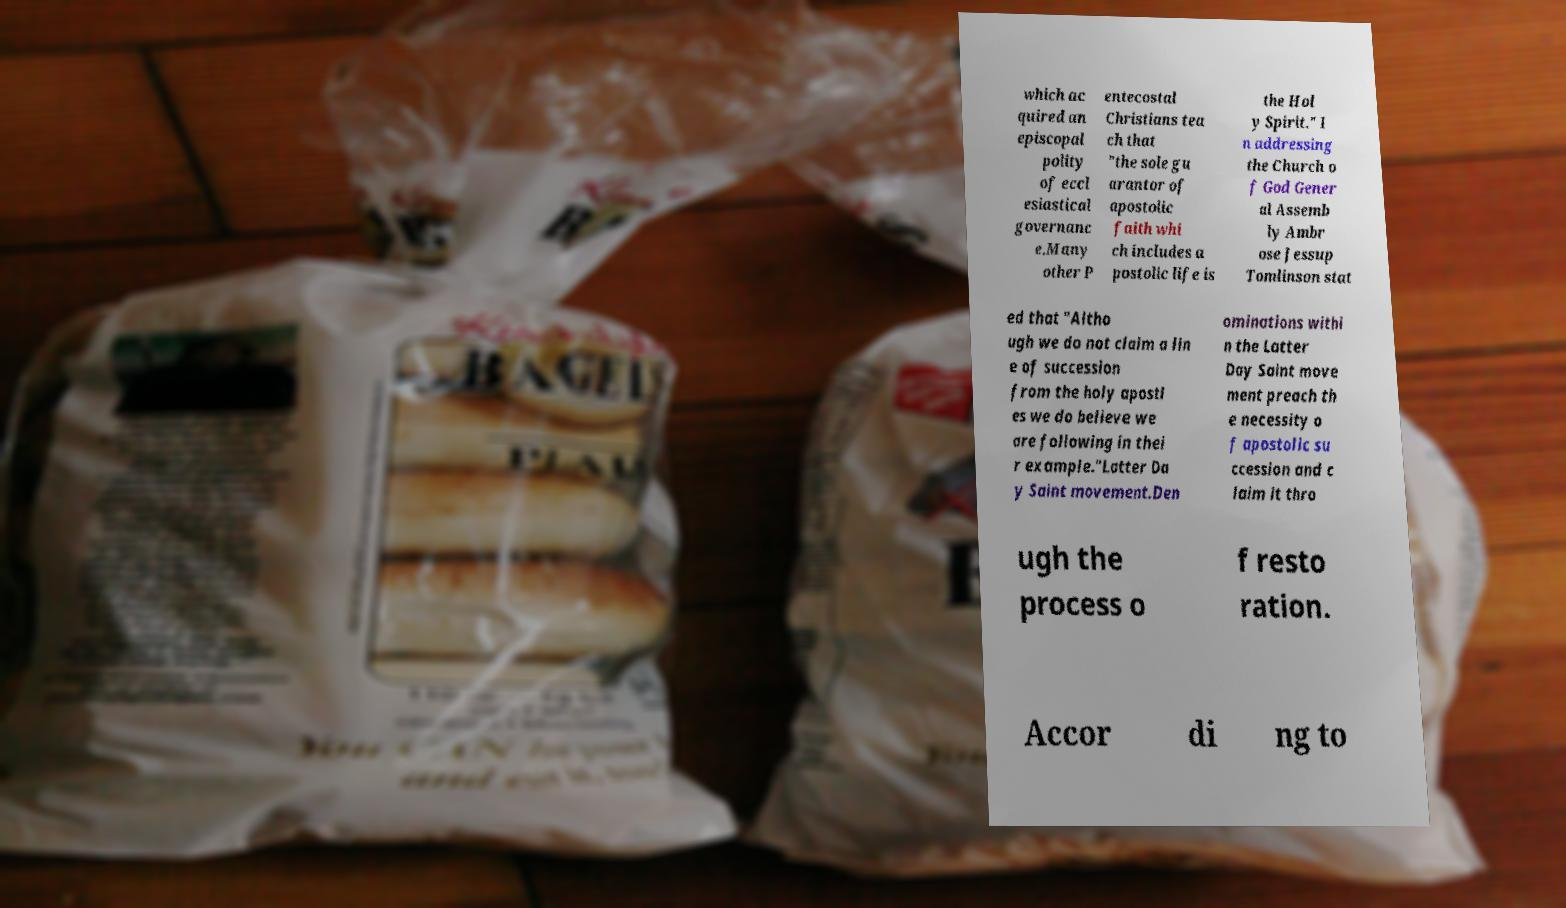For documentation purposes, I need the text within this image transcribed. Could you provide that? which ac quired an episcopal polity of eccl esiastical governanc e.Many other P entecostal Christians tea ch that "the sole gu arantor of apostolic faith whi ch includes a postolic life is the Hol y Spirit." I n addressing the Church o f God Gener al Assemb ly Ambr ose Jessup Tomlinson stat ed that "Altho ugh we do not claim a lin e of succession from the holy apostl es we do believe we are following in thei r example."Latter Da y Saint movement.Den ominations withi n the Latter Day Saint move ment preach th e necessity o f apostolic su ccession and c laim it thro ugh the process o f resto ration. Accor di ng to 